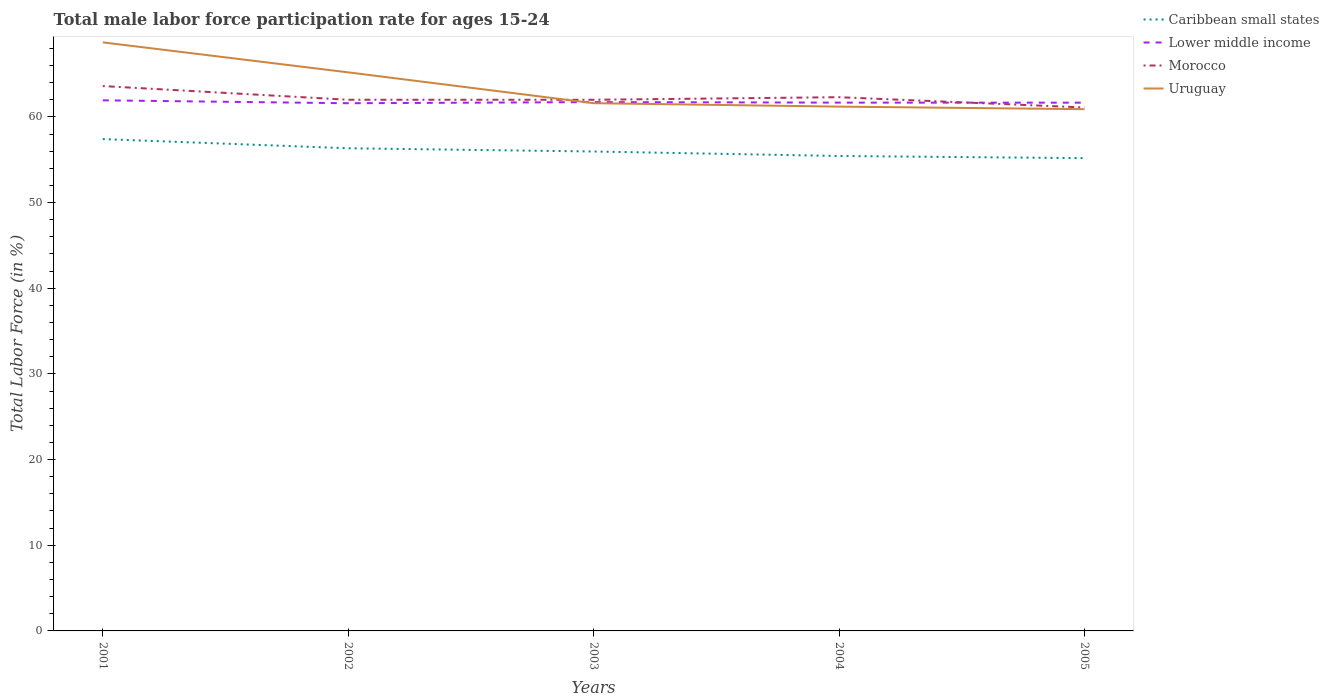How many different coloured lines are there?
Provide a succinct answer. 4. Is the number of lines equal to the number of legend labels?
Provide a short and direct response. Yes. Across all years, what is the maximum male labor force participation rate in Caribbean small states?
Provide a succinct answer. 55.18. What is the total male labor force participation rate in Morocco in the graph?
Your answer should be compact. 0.9. What is the difference between the highest and the second highest male labor force participation rate in Caribbean small states?
Keep it short and to the point. 2.22. What is the difference between the highest and the lowest male labor force participation rate in Morocco?
Make the answer very short. 2. Is the male labor force participation rate in Uruguay strictly greater than the male labor force participation rate in Caribbean small states over the years?
Your response must be concise. No. Does the graph contain grids?
Ensure brevity in your answer.  No. What is the title of the graph?
Offer a very short reply. Total male labor force participation rate for ages 15-24. Does "Cuba" appear as one of the legend labels in the graph?
Provide a short and direct response. No. What is the label or title of the X-axis?
Offer a terse response. Years. What is the Total Labor Force (in %) in Caribbean small states in 2001?
Ensure brevity in your answer.  57.41. What is the Total Labor Force (in %) of Lower middle income in 2001?
Keep it short and to the point. 61.93. What is the Total Labor Force (in %) of Morocco in 2001?
Keep it short and to the point. 63.6. What is the Total Labor Force (in %) in Uruguay in 2001?
Provide a succinct answer. 68.7. What is the Total Labor Force (in %) in Caribbean small states in 2002?
Provide a succinct answer. 56.34. What is the Total Labor Force (in %) of Lower middle income in 2002?
Ensure brevity in your answer.  61.59. What is the Total Labor Force (in %) of Morocco in 2002?
Ensure brevity in your answer.  62. What is the Total Labor Force (in %) in Uruguay in 2002?
Make the answer very short. 65.2. What is the Total Labor Force (in %) in Caribbean small states in 2003?
Provide a short and direct response. 55.96. What is the Total Labor Force (in %) in Lower middle income in 2003?
Offer a very short reply. 61.73. What is the Total Labor Force (in %) of Morocco in 2003?
Give a very brief answer. 62. What is the Total Labor Force (in %) of Uruguay in 2003?
Ensure brevity in your answer.  61.6. What is the Total Labor Force (in %) in Caribbean small states in 2004?
Provide a short and direct response. 55.44. What is the Total Labor Force (in %) of Lower middle income in 2004?
Provide a succinct answer. 61.67. What is the Total Labor Force (in %) of Morocco in 2004?
Make the answer very short. 62.3. What is the Total Labor Force (in %) in Uruguay in 2004?
Keep it short and to the point. 61.2. What is the Total Labor Force (in %) in Caribbean small states in 2005?
Keep it short and to the point. 55.18. What is the Total Labor Force (in %) in Lower middle income in 2005?
Keep it short and to the point. 61.66. What is the Total Labor Force (in %) in Morocco in 2005?
Provide a short and direct response. 61.1. What is the Total Labor Force (in %) of Uruguay in 2005?
Provide a short and direct response. 60.9. Across all years, what is the maximum Total Labor Force (in %) in Caribbean small states?
Your answer should be compact. 57.41. Across all years, what is the maximum Total Labor Force (in %) of Lower middle income?
Keep it short and to the point. 61.93. Across all years, what is the maximum Total Labor Force (in %) in Morocco?
Ensure brevity in your answer.  63.6. Across all years, what is the maximum Total Labor Force (in %) in Uruguay?
Keep it short and to the point. 68.7. Across all years, what is the minimum Total Labor Force (in %) in Caribbean small states?
Your answer should be very brief. 55.18. Across all years, what is the minimum Total Labor Force (in %) in Lower middle income?
Make the answer very short. 61.59. Across all years, what is the minimum Total Labor Force (in %) of Morocco?
Keep it short and to the point. 61.1. Across all years, what is the minimum Total Labor Force (in %) in Uruguay?
Your response must be concise. 60.9. What is the total Total Labor Force (in %) in Caribbean small states in the graph?
Provide a succinct answer. 280.33. What is the total Total Labor Force (in %) of Lower middle income in the graph?
Your answer should be compact. 308.58. What is the total Total Labor Force (in %) of Morocco in the graph?
Your response must be concise. 311. What is the total Total Labor Force (in %) in Uruguay in the graph?
Your response must be concise. 317.6. What is the difference between the Total Labor Force (in %) in Caribbean small states in 2001 and that in 2002?
Provide a short and direct response. 1.07. What is the difference between the Total Labor Force (in %) in Lower middle income in 2001 and that in 2002?
Your answer should be compact. 0.34. What is the difference between the Total Labor Force (in %) in Morocco in 2001 and that in 2002?
Keep it short and to the point. 1.6. What is the difference between the Total Labor Force (in %) of Uruguay in 2001 and that in 2002?
Make the answer very short. 3.5. What is the difference between the Total Labor Force (in %) in Caribbean small states in 2001 and that in 2003?
Give a very brief answer. 1.45. What is the difference between the Total Labor Force (in %) in Lower middle income in 2001 and that in 2003?
Your answer should be very brief. 0.21. What is the difference between the Total Labor Force (in %) in Uruguay in 2001 and that in 2003?
Provide a succinct answer. 7.1. What is the difference between the Total Labor Force (in %) in Caribbean small states in 2001 and that in 2004?
Make the answer very short. 1.97. What is the difference between the Total Labor Force (in %) of Lower middle income in 2001 and that in 2004?
Your response must be concise. 0.27. What is the difference between the Total Labor Force (in %) in Uruguay in 2001 and that in 2004?
Offer a terse response. 7.5. What is the difference between the Total Labor Force (in %) in Caribbean small states in 2001 and that in 2005?
Provide a short and direct response. 2.22. What is the difference between the Total Labor Force (in %) of Lower middle income in 2001 and that in 2005?
Your answer should be very brief. 0.27. What is the difference between the Total Labor Force (in %) of Caribbean small states in 2002 and that in 2003?
Your answer should be very brief. 0.38. What is the difference between the Total Labor Force (in %) in Lower middle income in 2002 and that in 2003?
Make the answer very short. -0.13. What is the difference between the Total Labor Force (in %) in Morocco in 2002 and that in 2003?
Keep it short and to the point. 0. What is the difference between the Total Labor Force (in %) of Uruguay in 2002 and that in 2003?
Your response must be concise. 3.6. What is the difference between the Total Labor Force (in %) in Caribbean small states in 2002 and that in 2004?
Provide a succinct answer. 0.9. What is the difference between the Total Labor Force (in %) of Lower middle income in 2002 and that in 2004?
Your response must be concise. -0.07. What is the difference between the Total Labor Force (in %) in Uruguay in 2002 and that in 2004?
Provide a succinct answer. 4. What is the difference between the Total Labor Force (in %) in Caribbean small states in 2002 and that in 2005?
Your answer should be very brief. 1.15. What is the difference between the Total Labor Force (in %) in Lower middle income in 2002 and that in 2005?
Give a very brief answer. -0.07. What is the difference between the Total Labor Force (in %) of Caribbean small states in 2003 and that in 2004?
Offer a very short reply. 0.52. What is the difference between the Total Labor Force (in %) of Lower middle income in 2003 and that in 2004?
Provide a succinct answer. 0.06. What is the difference between the Total Labor Force (in %) in Morocco in 2003 and that in 2004?
Make the answer very short. -0.3. What is the difference between the Total Labor Force (in %) in Caribbean small states in 2003 and that in 2005?
Offer a terse response. 0.78. What is the difference between the Total Labor Force (in %) in Lower middle income in 2003 and that in 2005?
Keep it short and to the point. 0.07. What is the difference between the Total Labor Force (in %) of Morocco in 2003 and that in 2005?
Your answer should be compact. 0.9. What is the difference between the Total Labor Force (in %) of Caribbean small states in 2004 and that in 2005?
Offer a terse response. 0.25. What is the difference between the Total Labor Force (in %) of Lower middle income in 2004 and that in 2005?
Provide a succinct answer. 0.01. What is the difference between the Total Labor Force (in %) in Caribbean small states in 2001 and the Total Labor Force (in %) in Lower middle income in 2002?
Your answer should be compact. -4.19. What is the difference between the Total Labor Force (in %) in Caribbean small states in 2001 and the Total Labor Force (in %) in Morocco in 2002?
Offer a very short reply. -4.59. What is the difference between the Total Labor Force (in %) in Caribbean small states in 2001 and the Total Labor Force (in %) in Uruguay in 2002?
Your answer should be compact. -7.79. What is the difference between the Total Labor Force (in %) in Lower middle income in 2001 and the Total Labor Force (in %) in Morocco in 2002?
Your answer should be compact. -0.07. What is the difference between the Total Labor Force (in %) of Lower middle income in 2001 and the Total Labor Force (in %) of Uruguay in 2002?
Make the answer very short. -3.27. What is the difference between the Total Labor Force (in %) in Caribbean small states in 2001 and the Total Labor Force (in %) in Lower middle income in 2003?
Your answer should be compact. -4.32. What is the difference between the Total Labor Force (in %) of Caribbean small states in 2001 and the Total Labor Force (in %) of Morocco in 2003?
Make the answer very short. -4.59. What is the difference between the Total Labor Force (in %) of Caribbean small states in 2001 and the Total Labor Force (in %) of Uruguay in 2003?
Ensure brevity in your answer.  -4.19. What is the difference between the Total Labor Force (in %) of Lower middle income in 2001 and the Total Labor Force (in %) of Morocco in 2003?
Offer a very short reply. -0.07. What is the difference between the Total Labor Force (in %) of Lower middle income in 2001 and the Total Labor Force (in %) of Uruguay in 2003?
Offer a terse response. 0.33. What is the difference between the Total Labor Force (in %) of Morocco in 2001 and the Total Labor Force (in %) of Uruguay in 2003?
Provide a succinct answer. 2. What is the difference between the Total Labor Force (in %) in Caribbean small states in 2001 and the Total Labor Force (in %) in Lower middle income in 2004?
Your response must be concise. -4.26. What is the difference between the Total Labor Force (in %) of Caribbean small states in 2001 and the Total Labor Force (in %) of Morocco in 2004?
Make the answer very short. -4.89. What is the difference between the Total Labor Force (in %) in Caribbean small states in 2001 and the Total Labor Force (in %) in Uruguay in 2004?
Ensure brevity in your answer.  -3.79. What is the difference between the Total Labor Force (in %) of Lower middle income in 2001 and the Total Labor Force (in %) of Morocco in 2004?
Your response must be concise. -0.37. What is the difference between the Total Labor Force (in %) of Lower middle income in 2001 and the Total Labor Force (in %) of Uruguay in 2004?
Your answer should be very brief. 0.73. What is the difference between the Total Labor Force (in %) in Morocco in 2001 and the Total Labor Force (in %) in Uruguay in 2004?
Keep it short and to the point. 2.4. What is the difference between the Total Labor Force (in %) in Caribbean small states in 2001 and the Total Labor Force (in %) in Lower middle income in 2005?
Give a very brief answer. -4.25. What is the difference between the Total Labor Force (in %) of Caribbean small states in 2001 and the Total Labor Force (in %) of Morocco in 2005?
Your response must be concise. -3.69. What is the difference between the Total Labor Force (in %) of Caribbean small states in 2001 and the Total Labor Force (in %) of Uruguay in 2005?
Your answer should be compact. -3.49. What is the difference between the Total Labor Force (in %) of Lower middle income in 2001 and the Total Labor Force (in %) of Morocco in 2005?
Your answer should be very brief. 0.83. What is the difference between the Total Labor Force (in %) of Lower middle income in 2001 and the Total Labor Force (in %) of Uruguay in 2005?
Your response must be concise. 1.03. What is the difference between the Total Labor Force (in %) in Morocco in 2001 and the Total Labor Force (in %) in Uruguay in 2005?
Provide a short and direct response. 2.7. What is the difference between the Total Labor Force (in %) in Caribbean small states in 2002 and the Total Labor Force (in %) in Lower middle income in 2003?
Give a very brief answer. -5.39. What is the difference between the Total Labor Force (in %) in Caribbean small states in 2002 and the Total Labor Force (in %) in Morocco in 2003?
Offer a terse response. -5.66. What is the difference between the Total Labor Force (in %) in Caribbean small states in 2002 and the Total Labor Force (in %) in Uruguay in 2003?
Keep it short and to the point. -5.26. What is the difference between the Total Labor Force (in %) of Lower middle income in 2002 and the Total Labor Force (in %) of Morocco in 2003?
Provide a succinct answer. -0.41. What is the difference between the Total Labor Force (in %) of Lower middle income in 2002 and the Total Labor Force (in %) of Uruguay in 2003?
Offer a very short reply. -0.01. What is the difference between the Total Labor Force (in %) of Morocco in 2002 and the Total Labor Force (in %) of Uruguay in 2003?
Your response must be concise. 0.4. What is the difference between the Total Labor Force (in %) in Caribbean small states in 2002 and the Total Labor Force (in %) in Lower middle income in 2004?
Give a very brief answer. -5.33. What is the difference between the Total Labor Force (in %) in Caribbean small states in 2002 and the Total Labor Force (in %) in Morocco in 2004?
Provide a short and direct response. -5.96. What is the difference between the Total Labor Force (in %) of Caribbean small states in 2002 and the Total Labor Force (in %) of Uruguay in 2004?
Provide a short and direct response. -4.86. What is the difference between the Total Labor Force (in %) of Lower middle income in 2002 and the Total Labor Force (in %) of Morocco in 2004?
Offer a terse response. -0.71. What is the difference between the Total Labor Force (in %) in Lower middle income in 2002 and the Total Labor Force (in %) in Uruguay in 2004?
Your answer should be compact. 0.39. What is the difference between the Total Labor Force (in %) of Morocco in 2002 and the Total Labor Force (in %) of Uruguay in 2004?
Your answer should be very brief. 0.8. What is the difference between the Total Labor Force (in %) of Caribbean small states in 2002 and the Total Labor Force (in %) of Lower middle income in 2005?
Offer a terse response. -5.32. What is the difference between the Total Labor Force (in %) in Caribbean small states in 2002 and the Total Labor Force (in %) in Morocco in 2005?
Give a very brief answer. -4.76. What is the difference between the Total Labor Force (in %) in Caribbean small states in 2002 and the Total Labor Force (in %) in Uruguay in 2005?
Make the answer very short. -4.56. What is the difference between the Total Labor Force (in %) in Lower middle income in 2002 and the Total Labor Force (in %) in Morocco in 2005?
Provide a short and direct response. 0.49. What is the difference between the Total Labor Force (in %) of Lower middle income in 2002 and the Total Labor Force (in %) of Uruguay in 2005?
Your response must be concise. 0.69. What is the difference between the Total Labor Force (in %) of Morocco in 2002 and the Total Labor Force (in %) of Uruguay in 2005?
Keep it short and to the point. 1.1. What is the difference between the Total Labor Force (in %) of Caribbean small states in 2003 and the Total Labor Force (in %) of Lower middle income in 2004?
Make the answer very short. -5.71. What is the difference between the Total Labor Force (in %) in Caribbean small states in 2003 and the Total Labor Force (in %) in Morocco in 2004?
Offer a terse response. -6.34. What is the difference between the Total Labor Force (in %) in Caribbean small states in 2003 and the Total Labor Force (in %) in Uruguay in 2004?
Provide a short and direct response. -5.24. What is the difference between the Total Labor Force (in %) of Lower middle income in 2003 and the Total Labor Force (in %) of Morocco in 2004?
Make the answer very short. -0.57. What is the difference between the Total Labor Force (in %) of Lower middle income in 2003 and the Total Labor Force (in %) of Uruguay in 2004?
Your answer should be very brief. 0.53. What is the difference between the Total Labor Force (in %) of Morocco in 2003 and the Total Labor Force (in %) of Uruguay in 2004?
Give a very brief answer. 0.8. What is the difference between the Total Labor Force (in %) in Caribbean small states in 2003 and the Total Labor Force (in %) in Lower middle income in 2005?
Your answer should be compact. -5.7. What is the difference between the Total Labor Force (in %) in Caribbean small states in 2003 and the Total Labor Force (in %) in Morocco in 2005?
Ensure brevity in your answer.  -5.14. What is the difference between the Total Labor Force (in %) in Caribbean small states in 2003 and the Total Labor Force (in %) in Uruguay in 2005?
Offer a terse response. -4.94. What is the difference between the Total Labor Force (in %) of Lower middle income in 2003 and the Total Labor Force (in %) of Morocco in 2005?
Give a very brief answer. 0.63. What is the difference between the Total Labor Force (in %) of Lower middle income in 2003 and the Total Labor Force (in %) of Uruguay in 2005?
Make the answer very short. 0.83. What is the difference between the Total Labor Force (in %) in Morocco in 2003 and the Total Labor Force (in %) in Uruguay in 2005?
Offer a very short reply. 1.1. What is the difference between the Total Labor Force (in %) in Caribbean small states in 2004 and the Total Labor Force (in %) in Lower middle income in 2005?
Ensure brevity in your answer.  -6.22. What is the difference between the Total Labor Force (in %) of Caribbean small states in 2004 and the Total Labor Force (in %) of Morocco in 2005?
Provide a succinct answer. -5.66. What is the difference between the Total Labor Force (in %) in Caribbean small states in 2004 and the Total Labor Force (in %) in Uruguay in 2005?
Your answer should be very brief. -5.46. What is the difference between the Total Labor Force (in %) in Lower middle income in 2004 and the Total Labor Force (in %) in Morocco in 2005?
Offer a very short reply. 0.57. What is the difference between the Total Labor Force (in %) of Lower middle income in 2004 and the Total Labor Force (in %) of Uruguay in 2005?
Make the answer very short. 0.77. What is the average Total Labor Force (in %) in Caribbean small states per year?
Your response must be concise. 56.07. What is the average Total Labor Force (in %) in Lower middle income per year?
Provide a succinct answer. 61.72. What is the average Total Labor Force (in %) of Morocco per year?
Offer a terse response. 62.2. What is the average Total Labor Force (in %) of Uruguay per year?
Your answer should be very brief. 63.52. In the year 2001, what is the difference between the Total Labor Force (in %) of Caribbean small states and Total Labor Force (in %) of Lower middle income?
Provide a succinct answer. -4.53. In the year 2001, what is the difference between the Total Labor Force (in %) in Caribbean small states and Total Labor Force (in %) in Morocco?
Offer a terse response. -6.19. In the year 2001, what is the difference between the Total Labor Force (in %) in Caribbean small states and Total Labor Force (in %) in Uruguay?
Offer a terse response. -11.29. In the year 2001, what is the difference between the Total Labor Force (in %) of Lower middle income and Total Labor Force (in %) of Morocco?
Make the answer very short. -1.67. In the year 2001, what is the difference between the Total Labor Force (in %) of Lower middle income and Total Labor Force (in %) of Uruguay?
Your answer should be compact. -6.77. In the year 2002, what is the difference between the Total Labor Force (in %) in Caribbean small states and Total Labor Force (in %) in Lower middle income?
Provide a succinct answer. -5.25. In the year 2002, what is the difference between the Total Labor Force (in %) in Caribbean small states and Total Labor Force (in %) in Morocco?
Your answer should be compact. -5.66. In the year 2002, what is the difference between the Total Labor Force (in %) in Caribbean small states and Total Labor Force (in %) in Uruguay?
Offer a terse response. -8.86. In the year 2002, what is the difference between the Total Labor Force (in %) in Lower middle income and Total Labor Force (in %) in Morocco?
Your answer should be compact. -0.41. In the year 2002, what is the difference between the Total Labor Force (in %) of Lower middle income and Total Labor Force (in %) of Uruguay?
Offer a very short reply. -3.61. In the year 2003, what is the difference between the Total Labor Force (in %) in Caribbean small states and Total Labor Force (in %) in Lower middle income?
Your response must be concise. -5.77. In the year 2003, what is the difference between the Total Labor Force (in %) of Caribbean small states and Total Labor Force (in %) of Morocco?
Offer a terse response. -6.04. In the year 2003, what is the difference between the Total Labor Force (in %) of Caribbean small states and Total Labor Force (in %) of Uruguay?
Your answer should be compact. -5.64. In the year 2003, what is the difference between the Total Labor Force (in %) in Lower middle income and Total Labor Force (in %) in Morocco?
Provide a short and direct response. -0.27. In the year 2003, what is the difference between the Total Labor Force (in %) in Lower middle income and Total Labor Force (in %) in Uruguay?
Provide a short and direct response. 0.13. In the year 2003, what is the difference between the Total Labor Force (in %) of Morocco and Total Labor Force (in %) of Uruguay?
Make the answer very short. 0.4. In the year 2004, what is the difference between the Total Labor Force (in %) in Caribbean small states and Total Labor Force (in %) in Lower middle income?
Make the answer very short. -6.23. In the year 2004, what is the difference between the Total Labor Force (in %) in Caribbean small states and Total Labor Force (in %) in Morocco?
Your answer should be very brief. -6.86. In the year 2004, what is the difference between the Total Labor Force (in %) of Caribbean small states and Total Labor Force (in %) of Uruguay?
Your response must be concise. -5.76. In the year 2004, what is the difference between the Total Labor Force (in %) of Lower middle income and Total Labor Force (in %) of Morocco?
Offer a terse response. -0.63. In the year 2004, what is the difference between the Total Labor Force (in %) of Lower middle income and Total Labor Force (in %) of Uruguay?
Your response must be concise. 0.47. In the year 2004, what is the difference between the Total Labor Force (in %) of Morocco and Total Labor Force (in %) of Uruguay?
Keep it short and to the point. 1.1. In the year 2005, what is the difference between the Total Labor Force (in %) in Caribbean small states and Total Labor Force (in %) in Lower middle income?
Your answer should be very brief. -6.48. In the year 2005, what is the difference between the Total Labor Force (in %) in Caribbean small states and Total Labor Force (in %) in Morocco?
Your response must be concise. -5.92. In the year 2005, what is the difference between the Total Labor Force (in %) of Caribbean small states and Total Labor Force (in %) of Uruguay?
Provide a succinct answer. -5.72. In the year 2005, what is the difference between the Total Labor Force (in %) in Lower middle income and Total Labor Force (in %) in Morocco?
Offer a terse response. 0.56. In the year 2005, what is the difference between the Total Labor Force (in %) in Lower middle income and Total Labor Force (in %) in Uruguay?
Provide a short and direct response. 0.76. In the year 2005, what is the difference between the Total Labor Force (in %) in Morocco and Total Labor Force (in %) in Uruguay?
Your answer should be very brief. 0.2. What is the ratio of the Total Labor Force (in %) in Morocco in 2001 to that in 2002?
Offer a terse response. 1.03. What is the ratio of the Total Labor Force (in %) of Uruguay in 2001 to that in 2002?
Offer a very short reply. 1.05. What is the ratio of the Total Labor Force (in %) of Caribbean small states in 2001 to that in 2003?
Offer a terse response. 1.03. What is the ratio of the Total Labor Force (in %) of Lower middle income in 2001 to that in 2003?
Offer a very short reply. 1. What is the ratio of the Total Labor Force (in %) in Morocco in 2001 to that in 2003?
Provide a short and direct response. 1.03. What is the ratio of the Total Labor Force (in %) of Uruguay in 2001 to that in 2003?
Ensure brevity in your answer.  1.12. What is the ratio of the Total Labor Force (in %) in Caribbean small states in 2001 to that in 2004?
Your answer should be compact. 1.04. What is the ratio of the Total Labor Force (in %) in Morocco in 2001 to that in 2004?
Offer a terse response. 1.02. What is the ratio of the Total Labor Force (in %) of Uruguay in 2001 to that in 2004?
Keep it short and to the point. 1.12. What is the ratio of the Total Labor Force (in %) of Caribbean small states in 2001 to that in 2005?
Give a very brief answer. 1.04. What is the ratio of the Total Labor Force (in %) of Morocco in 2001 to that in 2005?
Provide a short and direct response. 1.04. What is the ratio of the Total Labor Force (in %) of Uruguay in 2001 to that in 2005?
Your response must be concise. 1.13. What is the ratio of the Total Labor Force (in %) of Caribbean small states in 2002 to that in 2003?
Provide a short and direct response. 1.01. What is the ratio of the Total Labor Force (in %) in Uruguay in 2002 to that in 2003?
Provide a succinct answer. 1.06. What is the ratio of the Total Labor Force (in %) in Caribbean small states in 2002 to that in 2004?
Keep it short and to the point. 1.02. What is the ratio of the Total Labor Force (in %) in Lower middle income in 2002 to that in 2004?
Your response must be concise. 1. What is the ratio of the Total Labor Force (in %) of Morocco in 2002 to that in 2004?
Provide a succinct answer. 1. What is the ratio of the Total Labor Force (in %) of Uruguay in 2002 to that in 2004?
Keep it short and to the point. 1.07. What is the ratio of the Total Labor Force (in %) of Caribbean small states in 2002 to that in 2005?
Offer a very short reply. 1.02. What is the ratio of the Total Labor Force (in %) of Lower middle income in 2002 to that in 2005?
Make the answer very short. 1. What is the ratio of the Total Labor Force (in %) in Morocco in 2002 to that in 2005?
Your answer should be very brief. 1.01. What is the ratio of the Total Labor Force (in %) in Uruguay in 2002 to that in 2005?
Make the answer very short. 1.07. What is the ratio of the Total Labor Force (in %) of Caribbean small states in 2003 to that in 2004?
Keep it short and to the point. 1.01. What is the ratio of the Total Labor Force (in %) in Morocco in 2003 to that in 2004?
Your answer should be compact. 1. What is the ratio of the Total Labor Force (in %) of Caribbean small states in 2003 to that in 2005?
Offer a very short reply. 1.01. What is the ratio of the Total Labor Force (in %) in Morocco in 2003 to that in 2005?
Keep it short and to the point. 1.01. What is the ratio of the Total Labor Force (in %) in Uruguay in 2003 to that in 2005?
Ensure brevity in your answer.  1.01. What is the ratio of the Total Labor Force (in %) of Caribbean small states in 2004 to that in 2005?
Your answer should be compact. 1. What is the ratio of the Total Labor Force (in %) of Morocco in 2004 to that in 2005?
Your answer should be compact. 1.02. What is the ratio of the Total Labor Force (in %) in Uruguay in 2004 to that in 2005?
Keep it short and to the point. 1. What is the difference between the highest and the second highest Total Labor Force (in %) in Caribbean small states?
Ensure brevity in your answer.  1.07. What is the difference between the highest and the second highest Total Labor Force (in %) of Lower middle income?
Your answer should be compact. 0.21. What is the difference between the highest and the second highest Total Labor Force (in %) of Uruguay?
Keep it short and to the point. 3.5. What is the difference between the highest and the lowest Total Labor Force (in %) of Caribbean small states?
Offer a very short reply. 2.22. What is the difference between the highest and the lowest Total Labor Force (in %) of Lower middle income?
Offer a very short reply. 0.34. What is the difference between the highest and the lowest Total Labor Force (in %) in Morocco?
Ensure brevity in your answer.  2.5. What is the difference between the highest and the lowest Total Labor Force (in %) in Uruguay?
Ensure brevity in your answer.  7.8. 